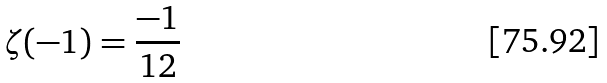<formula> <loc_0><loc_0><loc_500><loc_500>\zeta ( - 1 ) = \frac { - 1 } { 1 2 }</formula> 